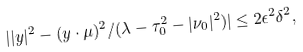<formula> <loc_0><loc_0><loc_500><loc_500>| | y | ^ { 2 } - ( y \cdot \mu ) ^ { 2 } / ( \lambda - \tau _ { 0 } ^ { 2 } - | \nu _ { 0 } | ^ { 2 } ) | \leq 2 \epsilon ^ { 2 } \delta ^ { 2 } ,</formula> 